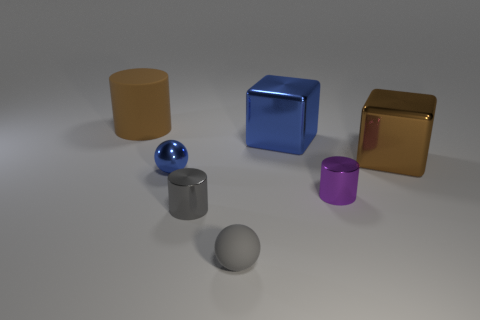How many purple things are the same size as the blue cube? There are no purple objects that are the exact same size as the blue cube in the image. The purple object present appears to be a cylinder which is smaller in height than the blue cube. 